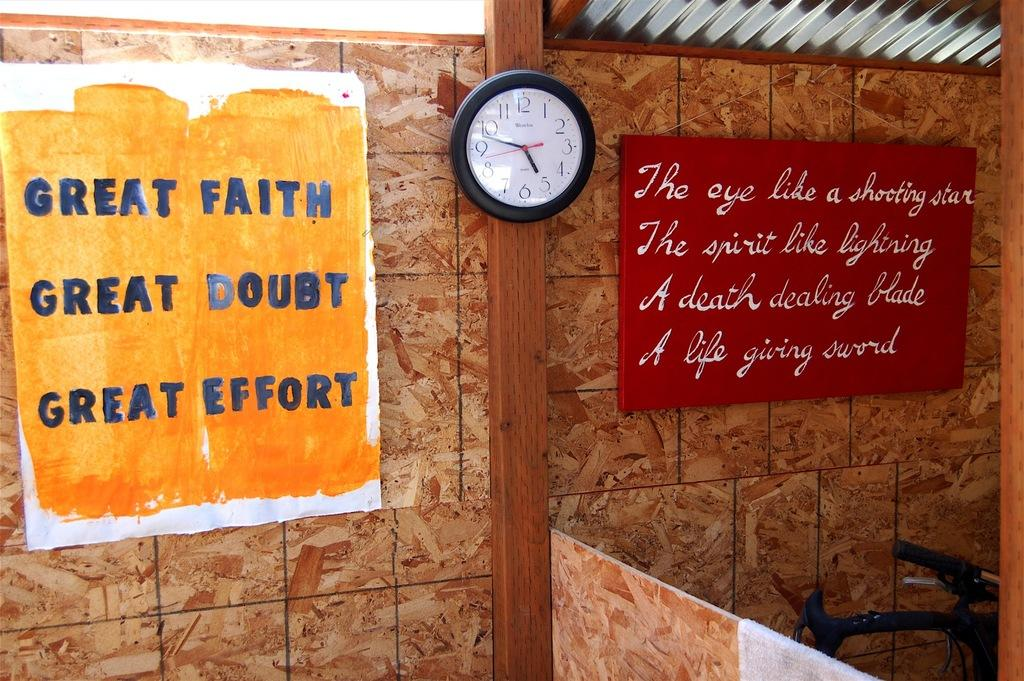<image>
Provide a brief description of the given image. A sign next to a clock says Great Faith, Great Doubt and Great Effort. 